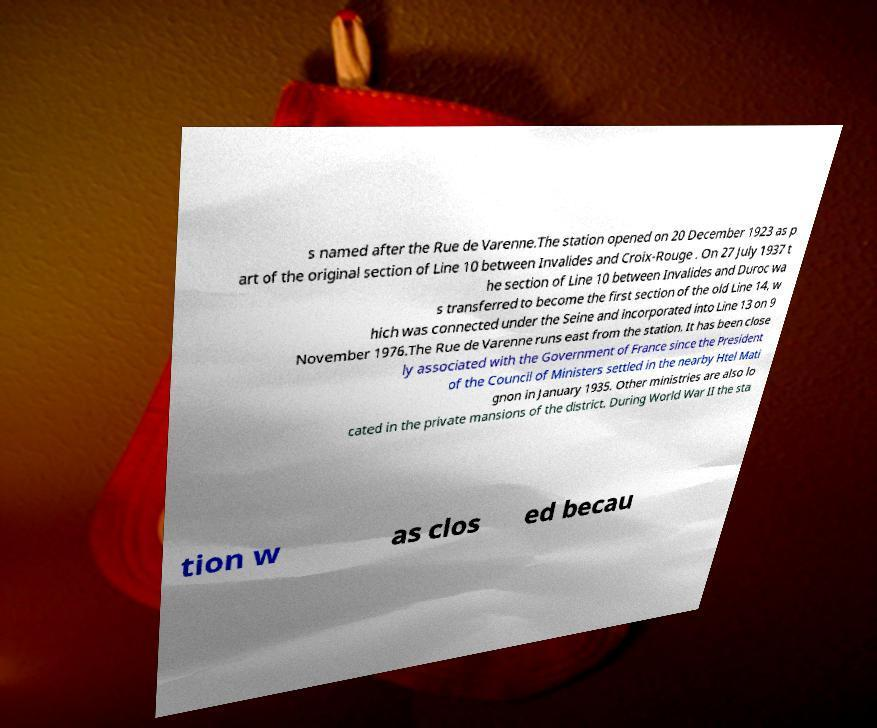I need the written content from this picture converted into text. Can you do that? s named after the Rue de Varenne.The station opened on 20 December 1923 as p art of the original section of Line 10 between Invalides and Croix-Rouge . On 27 July 1937 t he section of Line 10 between Invalides and Duroc wa s transferred to become the first section of the old Line 14, w hich was connected under the Seine and incorporated into Line 13 on 9 November 1976.The Rue de Varenne runs east from the station. It has been close ly associated with the Government of France since the President of the Council of Ministers settled in the nearby Htel Mati gnon in January 1935. Other ministries are also lo cated in the private mansions of the district. During World War II the sta tion w as clos ed becau 